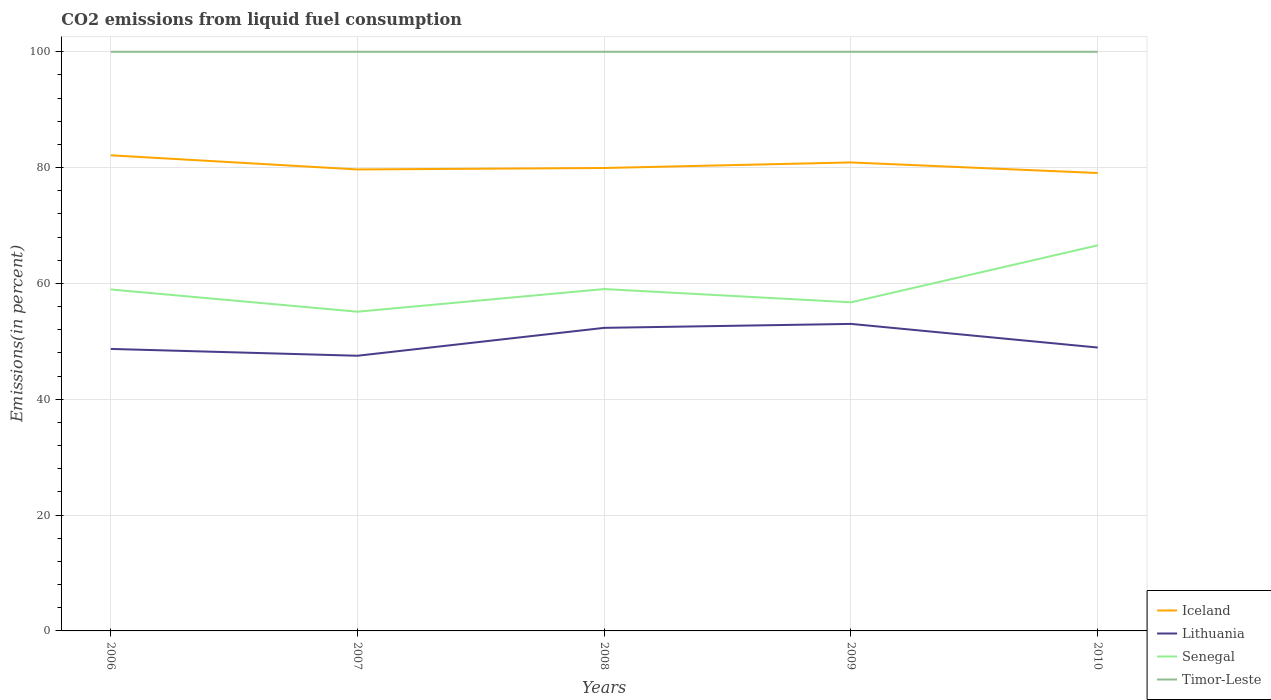How many different coloured lines are there?
Your answer should be very brief. 4. Does the line corresponding to Iceland intersect with the line corresponding to Senegal?
Give a very brief answer. No. Across all years, what is the maximum total CO2 emitted in Senegal?
Ensure brevity in your answer.  55.12. What is the total total CO2 emitted in Iceland in the graph?
Provide a succinct answer. 0.87. What is the difference between the highest and the second highest total CO2 emitted in Lithuania?
Your answer should be compact. 5.5. Is the total CO2 emitted in Senegal strictly greater than the total CO2 emitted in Lithuania over the years?
Offer a very short reply. No. How many lines are there?
Offer a terse response. 4. How many years are there in the graph?
Provide a succinct answer. 5. Does the graph contain grids?
Offer a very short reply. Yes. How are the legend labels stacked?
Your answer should be compact. Vertical. What is the title of the graph?
Keep it short and to the point. CO2 emissions from liquid fuel consumption. What is the label or title of the X-axis?
Your response must be concise. Years. What is the label or title of the Y-axis?
Your response must be concise. Emissions(in percent). What is the Emissions(in percent) of Iceland in 2006?
Offer a very short reply. 82.13. What is the Emissions(in percent) of Lithuania in 2006?
Provide a short and direct response. 48.69. What is the Emissions(in percent) in Senegal in 2006?
Keep it short and to the point. 58.96. What is the Emissions(in percent) in Timor-Leste in 2006?
Your answer should be compact. 100. What is the Emissions(in percent) in Iceland in 2007?
Your answer should be compact. 79.68. What is the Emissions(in percent) of Lithuania in 2007?
Make the answer very short. 47.51. What is the Emissions(in percent) of Senegal in 2007?
Provide a short and direct response. 55.12. What is the Emissions(in percent) in Timor-Leste in 2007?
Your answer should be very brief. 100. What is the Emissions(in percent) of Iceland in 2008?
Offer a very short reply. 79.93. What is the Emissions(in percent) of Lithuania in 2008?
Your response must be concise. 52.33. What is the Emissions(in percent) of Senegal in 2008?
Your response must be concise. 59.03. What is the Emissions(in percent) of Timor-Leste in 2008?
Your response must be concise. 100. What is the Emissions(in percent) in Iceland in 2009?
Offer a very short reply. 80.89. What is the Emissions(in percent) of Lithuania in 2009?
Provide a short and direct response. 53.01. What is the Emissions(in percent) of Senegal in 2009?
Make the answer very short. 56.74. What is the Emissions(in percent) of Iceland in 2010?
Offer a very short reply. 79.07. What is the Emissions(in percent) in Lithuania in 2010?
Offer a terse response. 48.93. What is the Emissions(in percent) in Senegal in 2010?
Keep it short and to the point. 66.58. What is the Emissions(in percent) in Timor-Leste in 2010?
Your response must be concise. 100. Across all years, what is the maximum Emissions(in percent) of Iceland?
Keep it short and to the point. 82.13. Across all years, what is the maximum Emissions(in percent) in Lithuania?
Your answer should be very brief. 53.01. Across all years, what is the maximum Emissions(in percent) of Senegal?
Provide a short and direct response. 66.58. Across all years, what is the minimum Emissions(in percent) of Iceland?
Keep it short and to the point. 79.07. Across all years, what is the minimum Emissions(in percent) in Lithuania?
Ensure brevity in your answer.  47.51. Across all years, what is the minimum Emissions(in percent) of Senegal?
Make the answer very short. 55.12. What is the total Emissions(in percent) of Iceland in the graph?
Provide a short and direct response. 401.7. What is the total Emissions(in percent) in Lithuania in the graph?
Provide a succinct answer. 250.48. What is the total Emissions(in percent) in Senegal in the graph?
Your answer should be compact. 296.43. What is the total Emissions(in percent) in Timor-Leste in the graph?
Keep it short and to the point. 500. What is the difference between the Emissions(in percent) of Iceland in 2006 and that in 2007?
Make the answer very short. 2.44. What is the difference between the Emissions(in percent) of Lithuania in 2006 and that in 2007?
Ensure brevity in your answer.  1.18. What is the difference between the Emissions(in percent) of Senegal in 2006 and that in 2007?
Your response must be concise. 3.84. What is the difference between the Emissions(in percent) in Timor-Leste in 2006 and that in 2007?
Your answer should be compact. 0. What is the difference between the Emissions(in percent) of Iceland in 2006 and that in 2008?
Provide a succinct answer. 2.19. What is the difference between the Emissions(in percent) of Lithuania in 2006 and that in 2008?
Ensure brevity in your answer.  -3.64. What is the difference between the Emissions(in percent) in Senegal in 2006 and that in 2008?
Your answer should be compact. -0.07. What is the difference between the Emissions(in percent) of Iceland in 2006 and that in 2009?
Ensure brevity in your answer.  1.23. What is the difference between the Emissions(in percent) of Lithuania in 2006 and that in 2009?
Make the answer very short. -4.32. What is the difference between the Emissions(in percent) of Senegal in 2006 and that in 2009?
Your answer should be very brief. 2.22. What is the difference between the Emissions(in percent) in Timor-Leste in 2006 and that in 2009?
Offer a terse response. 0. What is the difference between the Emissions(in percent) of Iceland in 2006 and that in 2010?
Ensure brevity in your answer.  3.06. What is the difference between the Emissions(in percent) in Lithuania in 2006 and that in 2010?
Give a very brief answer. -0.24. What is the difference between the Emissions(in percent) of Senegal in 2006 and that in 2010?
Keep it short and to the point. -7.62. What is the difference between the Emissions(in percent) of Timor-Leste in 2006 and that in 2010?
Provide a succinct answer. 0. What is the difference between the Emissions(in percent) in Iceland in 2007 and that in 2008?
Provide a succinct answer. -0.25. What is the difference between the Emissions(in percent) of Lithuania in 2007 and that in 2008?
Keep it short and to the point. -4.82. What is the difference between the Emissions(in percent) of Senegal in 2007 and that in 2008?
Your answer should be compact. -3.91. What is the difference between the Emissions(in percent) in Timor-Leste in 2007 and that in 2008?
Provide a succinct answer. 0. What is the difference between the Emissions(in percent) in Iceland in 2007 and that in 2009?
Make the answer very short. -1.21. What is the difference between the Emissions(in percent) of Lithuania in 2007 and that in 2009?
Make the answer very short. -5.5. What is the difference between the Emissions(in percent) of Senegal in 2007 and that in 2009?
Ensure brevity in your answer.  -1.62. What is the difference between the Emissions(in percent) of Iceland in 2007 and that in 2010?
Provide a succinct answer. 0.62. What is the difference between the Emissions(in percent) of Lithuania in 2007 and that in 2010?
Your response must be concise. -1.42. What is the difference between the Emissions(in percent) in Senegal in 2007 and that in 2010?
Give a very brief answer. -11.46. What is the difference between the Emissions(in percent) in Timor-Leste in 2007 and that in 2010?
Keep it short and to the point. 0. What is the difference between the Emissions(in percent) of Iceland in 2008 and that in 2009?
Make the answer very short. -0.96. What is the difference between the Emissions(in percent) of Lithuania in 2008 and that in 2009?
Make the answer very short. -0.68. What is the difference between the Emissions(in percent) of Senegal in 2008 and that in 2009?
Provide a short and direct response. 2.29. What is the difference between the Emissions(in percent) in Timor-Leste in 2008 and that in 2009?
Your response must be concise. 0. What is the difference between the Emissions(in percent) of Iceland in 2008 and that in 2010?
Your answer should be very brief. 0.87. What is the difference between the Emissions(in percent) in Lithuania in 2008 and that in 2010?
Offer a very short reply. 3.4. What is the difference between the Emissions(in percent) in Senegal in 2008 and that in 2010?
Keep it short and to the point. -7.55. What is the difference between the Emissions(in percent) of Timor-Leste in 2008 and that in 2010?
Make the answer very short. 0. What is the difference between the Emissions(in percent) in Iceland in 2009 and that in 2010?
Provide a succinct answer. 1.83. What is the difference between the Emissions(in percent) of Lithuania in 2009 and that in 2010?
Your answer should be compact. 4.08. What is the difference between the Emissions(in percent) in Senegal in 2009 and that in 2010?
Offer a terse response. -9.84. What is the difference between the Emissions(in percent) in Iceland in 2006 and the Emissions(in percent) in Lithuania in 2007?
Your response must be concise. 34.61. What is the difference between the Emissions(in percent) in Iceland in 2006 and the Emissions(in percent) in Senegal in 2007?
Keep it short and to the point. 27.01. What is the difference between the Emissions(in percent) in Iceland in 2006 and the Emissions(in percent) in Timor-Leste in 2007?
Your answer should be compact. -17.87. What is the difference between the Emissions(in percent) in Lithuania in 2006 and the Emissions(in percent) in Senegal in 2007?
Your answer should be compact. -6.43. What is the difference between the Emissions(in percent) in Lithuania in 2006 and the Emissions(in percent) in Timor-Leste in 2007?
Offer a terse response. -51.31. What is the difference between the Emissions(in percent) in Senegal in 2006 and the Emissions(in percent) in Timor-Leste in 2007?
Provide a succinct answer. -41.04. What is the difference between the Emissions(in percent) in Iceland in 2006 and the Emissions(in percent) in Lithuania in 2008?
Provide a short and direct response. 29.79. What is the difference between the Emissions(in percent) in Iceland in 2006 and the Emissions(in percent) in Senegal in 2008?
Keep it short and to the point. 23.1. What is the difference between the Emissions(in percent) in Iceland in 2006 and the Emissions(in percent) in Timor-Leste in 2008?
Provide a succinct answer. -17.87. What is the difference between the Emissions(in percent) in Lithuania in 2006 and the Emissions(in percent) in Senegal in 2008?
Your answer should be compact. -10.34. What is the difference between the Emissions(in percent) in Lithuania in 2006 and the Emissions(in percent) in Timor-Leste in 2008?
Give a very brief answer. -51.31. What is the difference between the Emissions(in percent) of Senegal in 2006 and the Emissions(in percent) of Timor-Leste in 2008?
Ensure brevity in your answer.  -41.04. What is the difference between the Emissions(in percent) in Iceland in 2006 and the Emissions(in percent) in Lithuania in 2009?
Give a very brief answer. 29.11. What is the difference between the Emissions(in percent) in Iceland in 2006 and the Emissions(in percent) in Senegal in 2009?
Offer a terse response. 25.39. What is the difference between the Emissions(in percent) of Iceland in 2006 and the Emissions(in percent) of Timor-Leste in 2009?
Ensure brevity in your answer.  -17.87. What is the difference between the Emissions(in percent) of Lithuania in 2006 and the Emissions(in percent) of Senegal in 2009?
Keep it short and to the point. -8.05. What is the difference between the Emissions(in percent) of Lithuania in 2006 and the Emissions(in percent) of Timor-Leste in 2009?
Your response must be concise. -51.31. What is the difference between the Emissions(in percent) in Senegal in 2006 and the Emissions(in percent) in Timor-Leste in 2009?
Your answer should be compact. -41.04. What is the difference between the Emissions(in percent) in Iceland in 2006 and the Emissions(in percent) in Lithuania in 2010?
Give a very brief answer. 33.19. What is the difference between the Emissions(in percent) of Iceland in 2006 and the Emissions(in percent) of Senegal in 2010?
Provide a succinct answer. 15.55. What is the difference between the Emissions(in percent) in Iceland in 2006 and the Emissions(in percent) in Timor-Leste in 2010?
Offer a very short reply. -17.87. What is the difference between the Emissions(in percent) of Lithuania in 2006 and the Emissions(in percent) of Senegal in 2010?
Ensure brevity in your answer.  -17.89. What is the difference between the Emissions(in percent) of Lithuania in 2006 and the Emissions(in percent) of Timor-Leste in 2010?
Keep it short and to the point. -51.31. What is the difference between the Emissions(in percent) in Senegal in 2006 and the Emissions(in percent) in Timor-Leste in 2010?
Give a very brief answer. -41.04. What is the difference between the Emissions(in percent) of Iceland in 2007 and the Emissions(in percent) of Lithuania in 2008?
Your response must be concise. 27.35. What is the difference between the Emissions(in percent) in Iceland in 2007 and the Emissions(in percent) in Senegal in 2008?
Give a very brief answer. 20.65. What is the difference between the Emissions(in percent) in Iceland in 2007 and the Emissions(in percent) in Timor-Leste in 2008?
Offer a very short reply. -20.32. What is the difference between the Emissions(in percent) of Lithuania in 2007 and the Emissions(in percent) of Senegal in 2008?
Provide a short and direct response. -11.52. What is the difference between the Emissions(in percent) of Lithuania in 2007 and the Emissions(in percent) of Timor-Leste in 2008?
Keep it short and to the point. -52.49. What is the difference between the Emissions(in percent) in Senegal in 2007 and the Emissions(in percent) in Timor-Leste in 2008?
Your response must be concise. -44.88. What is the difference between the Emissions(in percent) in Iceland in 2007 and the Emissions(in percent) in Lithuania in 2009?
Provide a short and direct response. 26.67. What is the difference between the Emissions(in percent) of Iceland in 2007 and the Emissions(in percent) of Senegal in 2009?
Offer a very short reply. 22.94. What is the difference between the Emissions(in percent) of Iceland in 2007 and the Emissions(in percent) of Timor-Leste in 2009?
Keep it short and to the point. -20.32. What is the difference between the Emissions(in percent) in Lithuania in 2007 and the Emissions(in percent) in Senegal in 2009?
Offer a terse response. -9.23. What is the difference between the Emissions(in percent) of Lithuania in 2007 and the Emissions(in percent) of Timor-Leste in 2009?
Give a very brief answer. -52.49. What is the difference between the Emissions(in percent) in Senegal in 2007 and the Emissions(in percent) in Timor-Leste in 2009?
Keep it short and to the point. -44.88. What is the difference between the Emissions(in percent) of Iceland in 2007 and the Emissions(in percent) of Lithuania in 2010?
Your answer should be very brief. 30.75. What is the difference between the Emissions(in percent) in Iceland in 2007 and the Emissions(in percent) in Senegal in 2010?
Provide a succinct answer. 13.1. What is the difference between the Emissions(in percent) of Iceland in 2007 and the Emissions(in percent) of Timor-Leste in 2010?
Provide a short and direct response. -20.32. What is the difference between the Emissions(in percent) in Lithuania in 2007 and the Emissions(in percent) in Senegal in 2010?
Your response must be concise. -19.06. What is the difference between the Emissions(in percent) of Lithuania in 2007 and the Emissions(in percent) of Timor-Leste in 2010?
Give a very brief answer. -52.49. What is the difference between the Emissions(in percent) in Senegal in 2007 and the Emissions(in percent) in Timor-Leste in 2010?
Provide a short and direct response. -44.88. What is the difference between the Emissions(in percent) of Iceland in 2008 and the Emissions(in percent) of Lithuania in 2009?
Give a very brief answer. 26.92. What is the difference between the Emissions(in percent) in Iceland in 2008 and the Emissions(in percent) in Senegal in 2009?
Your response must be concise. 23.19. What is the difference between the Emissions(in percent) in Iceland in 2008 and the Emissions(in percent) in Timor-Leste in 2009?
Your answer should be compact. -20.07. What is the difference between the Emissions(in percent) in Lithuania in 2008 and the Emissions(in percent) in Senegal in 2009?
Ensure brevity in your answer.  -4.41. What is the difference between the Emissions(in percent) of Lithuania in 2008 and the Emissions(in percent) of Timor-Leste in 2009?
Ensure brevity in your answer.  -47.67. What is the difference between the Emissions(in percent) in Senegal in 2008 and the Emissions(in percent) in Timor-Leste in 2009?
Offer a terse response. -40.97. What is the difference between the Emissions(in percent) in Iceland in 2008 and the Emissions(in percent) in Lithuania in 2010?
Your answer should be compact. 31. What is the difference between the Emissions(in percent) of Iceland in 2008 and the Emissions(in percent) of Senegal in 2010?
Make the answer very short. 13.35. What is the difference between the Emissions(in percent) of Iceland in 2008 and the Emissions(in percent) of Timor-Leste in 2010?
Your answer should be compact. -20.07. What is the difference between the Emissions(in percent) of Lithuania in 2008 and the Emissions(in percent) of Senegal in 2010?
Provide a succinct answer. -14.25. What is the difference between the Emissions(in percent) of Lithuania in 2008 and the Emissions(in percent) of Timor-Leste in 2010?
Your answer should be very brief. -47.67. What is the difference between the Emissions(in percent) in Senegal in 2008 and the Emissions(in percent) in Timor-Leste in 2010?
Offer a terse response. -40.97. What is the difference between the Emissions(in percent) in Iceland in 2009 and the Emissions(in percent) in Lithuania in 2010?
Provide a succinct answer. 31.96. What is the difference between the Emissions(in percent) of Iceland in 2009 and the Emissions(in percent) of Senegal in 2010?
Your answer should be very brief. 14.31. What is the difference between the Emissions(in percent) in Iceland in 2009 and the Emissions(in percent) in Timor-Leste in 2010?
Give a very brief answer. -19.11. What is the difference between the Emissions(in percent) of Lithuania in 2009 and the Emissions(in percent) of Senegal in 2010?
Provide a short and direct response. -13.57. What is the difference between the Emissions(in percent) of Lithuania in 2009 and the Emissions(in percent) of Timor-Leste in 2010?
Your response must be concise. -46.99. What is the difference between the Emissions(in percent) in Senegal in 2009 and the Emissions(in percent) in Timor-Leste in 2010?
Keep it short and to the point. -43.26. What is the average Emissions(in percent) in Iceland per year?
Your answer should be very brief. 80.34. What is the average Emissions(in percent) of Lithuania per year?
Offer a very short reply. 50.1. What is the average Emissions(in percent) in Senegal per year?
Your answer should be very brief. 59.29. What is the average Emissions(in percent) of Timor-Leste per year?
Provide a short and direct response. 100. In the year 2006, what is the difference between the Emissions(in percent) in Iceland and Emissions(in percent) in Lithuania?
Your answer should be very brief. 33.43. In the year 2006, what is the difference between the Emissions(in percent) of Iceland and Emissions(in percent) of Senegal?
Give a very brief answer. 23.17. In the year 2006, what is the difference between the Emissions(in percent) in Iceland and Emissions(in percent) in Timor-Leste?
Give a very brief answer. -17.87. In the year 2006, what is the difference between the Emissions(in percent) of Lithuania and Emissions(in percent) of Senegal?
Make the answer very short. -10.27. In the year 2006, what is the difference between the Emissions(in percent) in Lithuania and Emissions(in percent) in Timor-Leste?
Give a very brief answer. -51.31. In the year 2006, what is the difference between the Emissions(in percent) in Senegal and Emissions(in percent) in Timor-Leste?
Provide a succinct answer. -41.04. In the year 2007, what is the difference between the Emissions(in percent) in Iceland and Emissions(in percent) in Lithuania?
Offer a terse response. 32.17. In the year 2007, what is the difference between the Emissions(in percent) of Iceland and Emissions(in percent) of Senegal?
Your answer should be compact. 24.56. In the year 2007, what is the difference between the Emissions(in percent) in Iceland and Emissions(in percent) in Timor-Leste?
Provide a short and direct response. -20.32. In the year 2007, what is the difference between the Emissions(in percent) in Lithuania and Emissions(in percent) in Senegal?
Offer a very short reply. -7.61. In the year 2007, what is the difference between the Emissions(in percent) in Lithuania and Emissions(in percent) in Timor-Leste?
Give a very brief answer. -52.49. In the year 2007, what is the difference between the Emissions(in percent) of Senegal and Emissions(in percent) of Timor-Leste?
Provide a short and direct response. -44.88. In the year 2008, what is the difference between the Emissions(in percent) in Iceland and Emissions(in percent) in Lithuania?
Offer a very short reply. 27.6. In the year 2008, what is the difference between the Emissions(in percent) of Iceland and Emissions(in percent) of Senegal?
Give a very brief answer. 20.9. In the year 2008, what is the difference between the Emissions(in percent) in Iceland and Emissions(in percent) in Timor-Leste?
Your answer should be compact. -20.07. In the year 2008, what is the difference between the Emissions(in percent) of Lithuania and Emissions(in percent) of Senegal?
Keep it short and to the point. -6.7. In the year 2008, what is the difference between the Emissions(in percent) in Lithuania and Emissions(in percent) in Timor-Leste?
Keep it short and to the point. -47.67. In the year 2008, what is the difference between the Emissions(in percent) of Senegal and Emissions(in percent) of Timor-Leste?
Keep it short and to the point. -40.97. In the year 2009, what is the difference between the Emissions(in percent) of Iceland and Emissions(in percent) of Lithuania?
Your response must be concise. 27.88. In the year 2009, what is the difference between the Emissions(in percent) of Iceland and Emissions(in percent) of Senegal?
Give a very brief answer. 24.15. In the year 2009, what is the difference between the Emissions(in percent) in Iceland and Emissions(in percent) in Timor-Leste?
Make the answer very short. -19.11. In the year 2009, what is the difference between the Emissions(in percent) of Lithuania and Emissions(in percent) of Senegal?
Keep it short and to the point. -3.73. In the year 2009, what is the difference between the Emissions(in percent) in Lithuania and Emissions(in percent) in Timor-Leste?
Make the answer very short. -46.99. In the year 2009, what is the difference between the Emissions(in percent) of Senegal and Emissions(in percent) of Timor-Leste?
Keep it short and to the point. -43.26. In the year 2010, what is the difference between the Emissions(in percent) of Iceland and Emissions(in percent) of Lithuania?
Give a very brief answer. 30.13. In the year 2010, what is the difference between the Emissions(in percent) of Iceland and Emissions(in percent) of Senegal?
Make the answer very short. 12.49. In the year 2010, what is the difference between the Emissions(in percent) of Iceland and Emissions(in percent) of Timor-Leste?
Keep it short and to the point. -20.93. In the year 2010, what is the difference between the Emissions(in percent) of Lithuania and Emissions(in percent) of Senegal?
Keep it short and to the point. -17.65. In the year 2010, what is the difference between the Emissions(in percent) in Lithuania and Emissions(in percent) in Timor-Leste?
Offer a terse response. -51.07. In the year 2010, what is the difference between the Emissions(in percent) of Senegal and Emissions(in percent) of Timor-Leste?
Provide a succinct answer. -33.42. What is the ratio of the Emissions(in percent) of Iceland in 2006 to that in 2007?
Ensure brevity in your answer.  1.03. What is the ratio of the Emissions(in percent) in Lithuania in 2006 to that in 2007?
Offer a terse response. 1.02. What is the ratio of the Emissions(in percent) in Senegal in 2006 to that in 2007?
Ensure brevity in your answer.  1.07. What is the ratio of the Emissions(in percent) in Timor-Leste in 2006 to that in 2007?
Offer a terse response. 1. What is the ratio of the Emissions(in percent) in Iceland in 2006 to that in 2008?
Provide a short and direct response. 1.03. What is the ratio of the Emissions(in percent) in Lithuania in 2006 to that in 2008?
Offer a terse response. 0.93. What is the ratio of the Emissions(in percent) in Senegal in 2006 to that in 2008?
Provide a succinct answer. 1. What is the ratio of the Emissions(in percent) of Iceland in 2006 to that in 2009?
Offer a terse response. 1.02. What is the ratio of the Emissions(in percent) in Lithuania in 2006 to that in 2009?
Your answer should be compact. 0.92. What is the ratio of the Emissions(in percent) of Senegal in 2006 to that in 2009?
Your answer should be compact. 1.04. What is the ratio of the Emissions(in percent) of Iceland in 2006 to that in 2010?
Offer a very short reply. 1.04. What is the ratio of the Emissions(in percent) of Lithuania in 2006 to that in 2010?
Offer a terse response. 1. What is the ratio of the Emissions(in percent) in Senegal in 2006 to that in 2010?
Your response must be concise. 0.89. What is the ratio of the Emissions(in percent) in Iceland in 2007 to that in 2008?
Give a very brief answer. 1. What is the ratio of the Emissions(in percent) of Lithuania in 2007 to that in 2008?
Offer a terse response. 0.91. What is the ratio of the Emissions(in percent) in Senegal in 2007 to that in 2008?
Keep it short and to the point. 0.93. What is the ratio of the Emissions(in percent) in Lithuania in 2007 to that in 2009?
Your answer should be very brief. 0.9. What is the ratio of the Emissions(in percent) of Senegal in 2007 to that in 2009?
Keep it short and to the point. 0.97. What is the ratio of the Emissions(in percent) of Senegal in 2007 to that in 2010?
Ensure brevity in your answer.  0.83. What is the ratio of the Emissions(in percent) in Timor-Leste in 2007 to that in 2010?
Offer a terse response. 1. What is the ratio of the Emissions(in percent) in Iceland in 2008 to that in 2009?
Offer a terse response. 0.99. What is the ratio of the Emissions(in percent) of Lithuania in 2008 to that in 2009?
Ensure brevity in your answer.  0.99. What is the ratio of the Emissions(in percent) of Senegal in 2008 to that in 2009?
Offer a terse response. 1.04. What is the ratio of the Emissions(in percent) of Iceland in 2008 to that in 2010?
Offer a very short reply. 1.01. What is the ratio of the Emissions(in percent) of Lithuania in 2008 to that in 2010?
Your response must be concise. 1.07. What is the ratio of the Emissions(in percent) of Senegal in 2008 to that in 2010?
Ensure brevity in your answer.  0.89. What is the ratio of the Emissions(in percent) of Iceland in 2009 to that in 2010?
Your response must be concise. 1.02. What is the ratio of the Emissions(in percent) in Lithuania in 2009 to that in 2010?
Provide a short and direct response. 1.08. What is the ratio of the Emissions(in percent) in Senegal in 2009 to that in 2010?
Keep it short and to the point. 0.85. What is the ratio of the Emissions(in percent) of Timor-Leste in 2009 to that in 2010?
Ensure brevity in your answer.  1. What is the difference between the highest and the second highest Emissions(in percent) of Iceland?
Ensure brevity in your answer.  1.23. What is the difference between the highest and the second highest Emissions(in percent) in Lithuania?
Your answer should be compact. 0.68. What is the difference between the highest and the second highest Emissions(in percent) of Senegal?
Provide a short and direct response. 7.55. What is the difference between the highest and the second highest Emissions(in percent) in Timor-Leste?
Provide a succinct answer. 0. What is the difference between the highest and the lowest Emissions(in percent) of Iceland?
Offer a very short reply. 3.06. What is the difference between the highest and the lowest Emissions(in percent) in Lithuania?
Offer a terse response. 5.5. What is the difference between the highest and the lowest Emissions(in percent) in Senegal?
Provide a short and direct response. 11.46. What is the difference between the highest and the lowest Emissions(in percent) of Timor-Leste?
Provide a short and direct response. 0. 